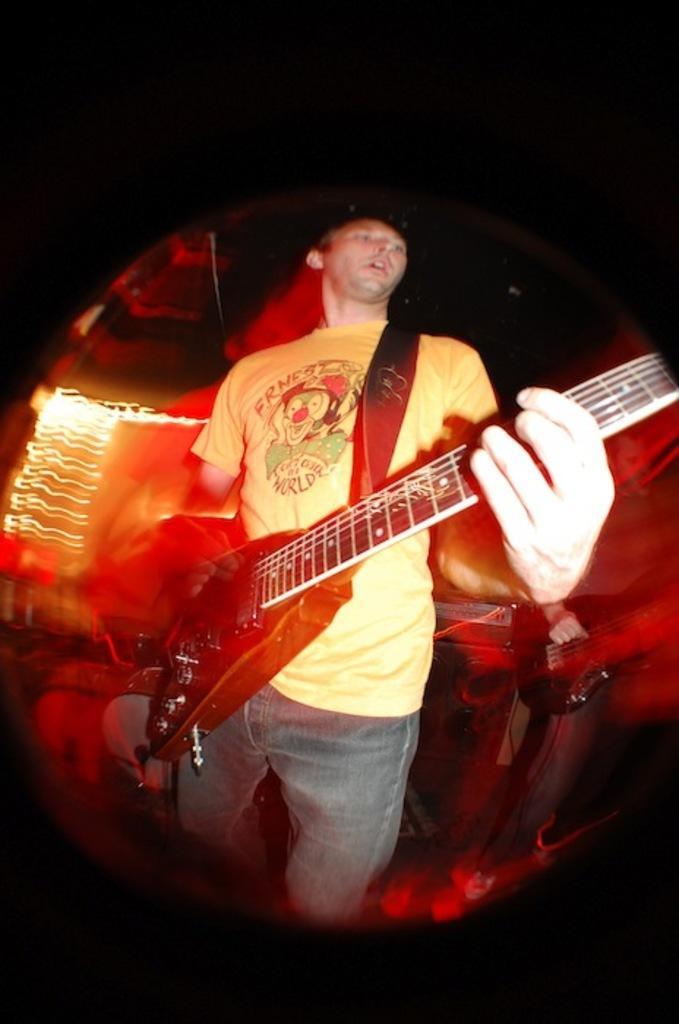In one or two sentences, can you explain what this image depicts? In this image i can see a person standing and holding a guitar. 